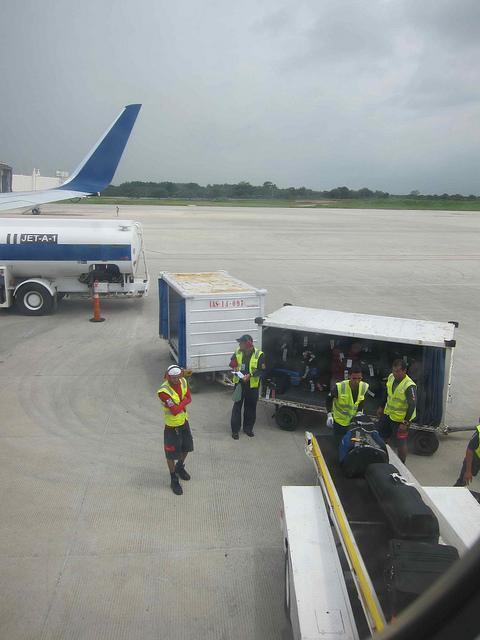How many men are wearing vests?
Give a very brief answer. 4. How many suitcases are in the photo?
Give a very brief answer. 3. How many people are in the photo?
Give a very brief answer. 3. How many trucks are there?
Give a very brief answer. 3. 